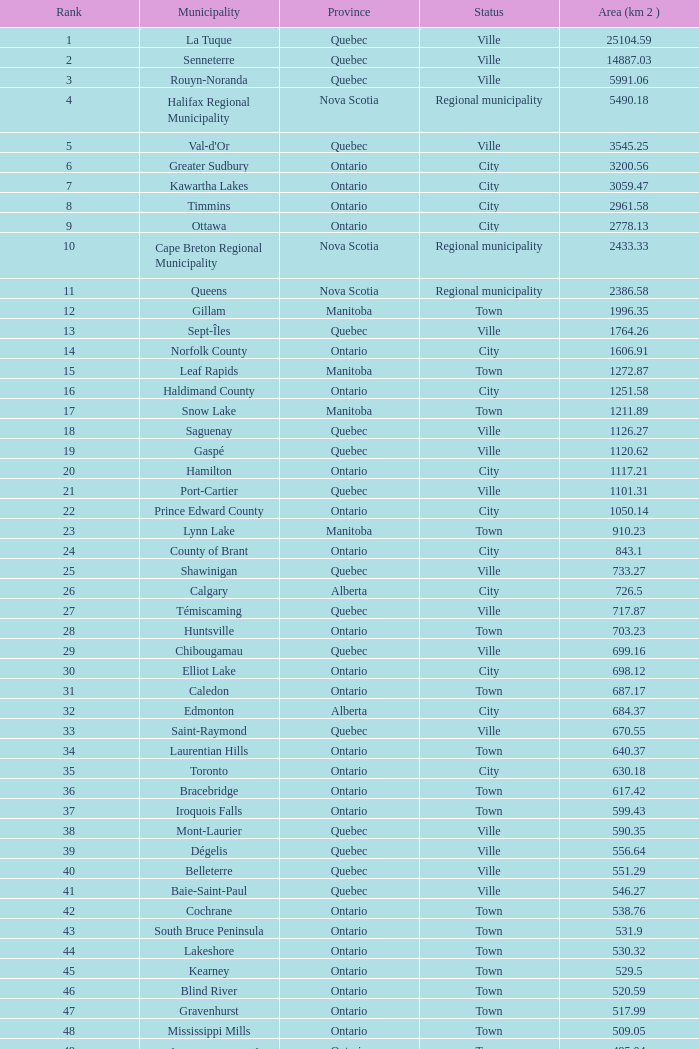In which municipality can the 44th rank be found? Lakeshore. 